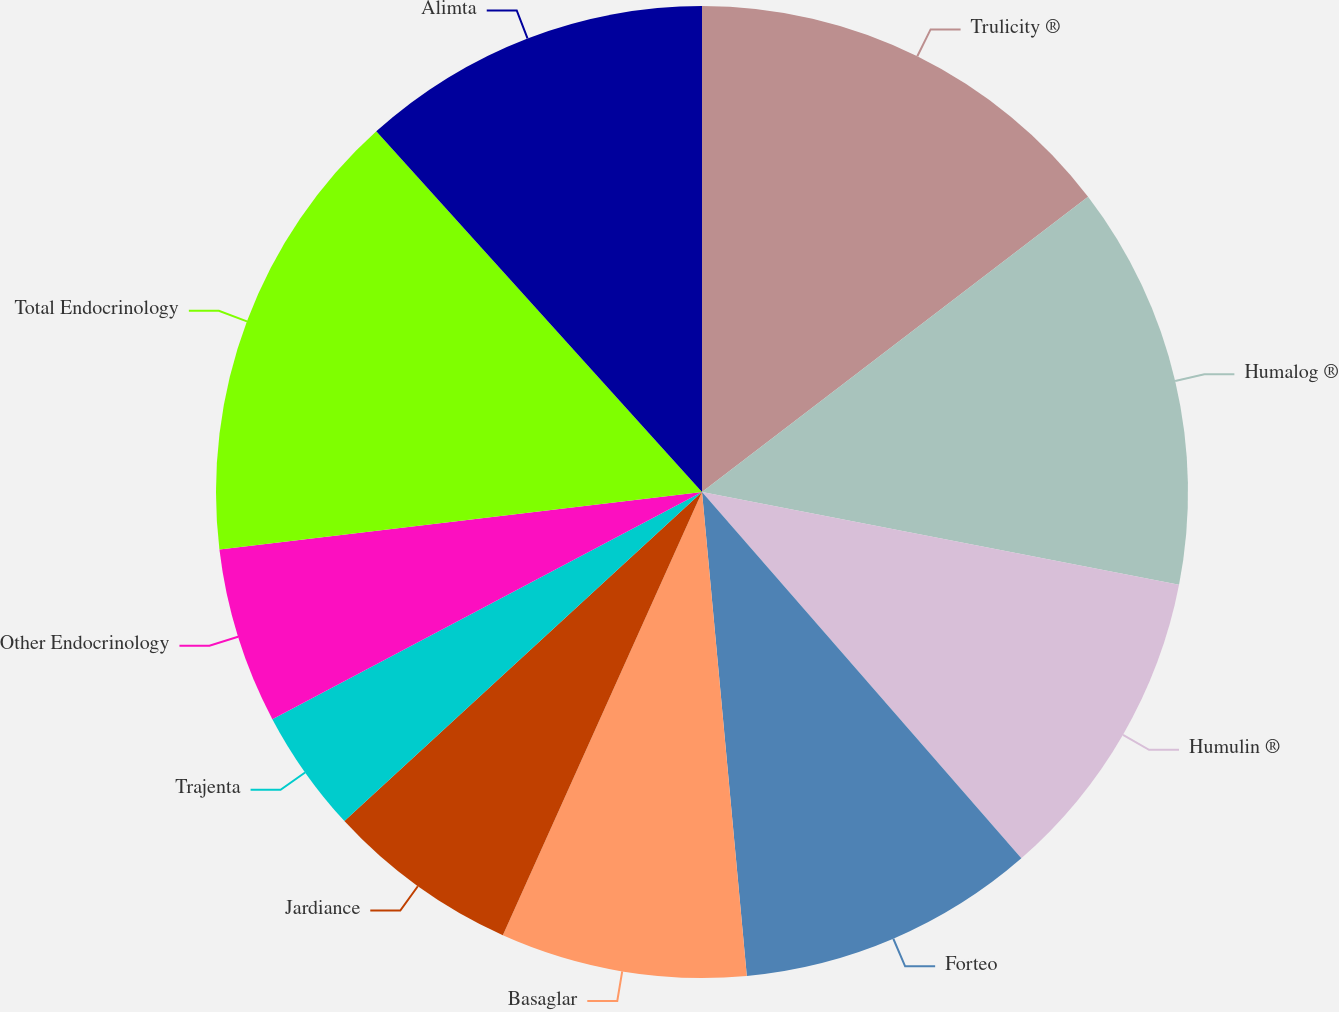Convert chart. <chart><loc_0><loc_0><loc_500><loc_500><pie_chart><fcel>Trulicity ®<fcel>Humalog ®<fcel>Humulin ®<fcel>Forteo<fcel>Basaglar<fcel>Jardiance<fcel>Trajenta<fcel>Other Endocrinology<fcel>Total Endocrinology<fcel>Alimta<nl><fcel>14.61%<fcel>13.45%<fcel>10.53%<fcel>9.94%<fcel>8.19%<fcel>6.44%<fcel>4.1%<fcel>5.85%<fcel>15.2%<fcel>11.69%<nl></chart> 